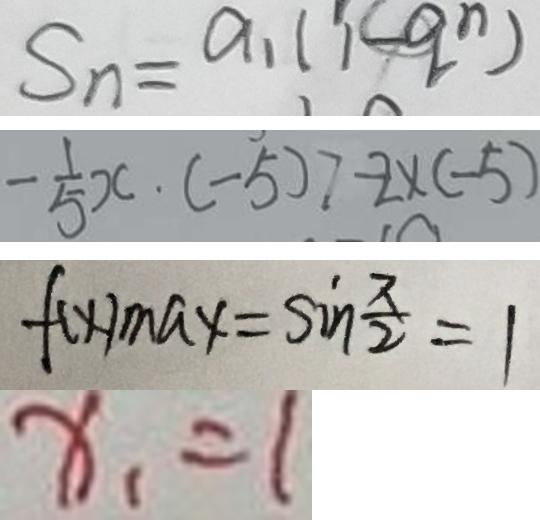Convert formula to latex. <formula><loc_0><loc_0><loc_500><loc_500>S _ { n } = a _ { 1 } ( 1 - q ^ { n } ) 
 - \frac { 1 } { 5 } x \cdot ( - 5 ) > - 2 \times ( - 5 ) 
 f ( x ) _ { \max } = \sin \frac { \pi } { 2 } = 1 
 x _ { 1 } = 1</formula> 